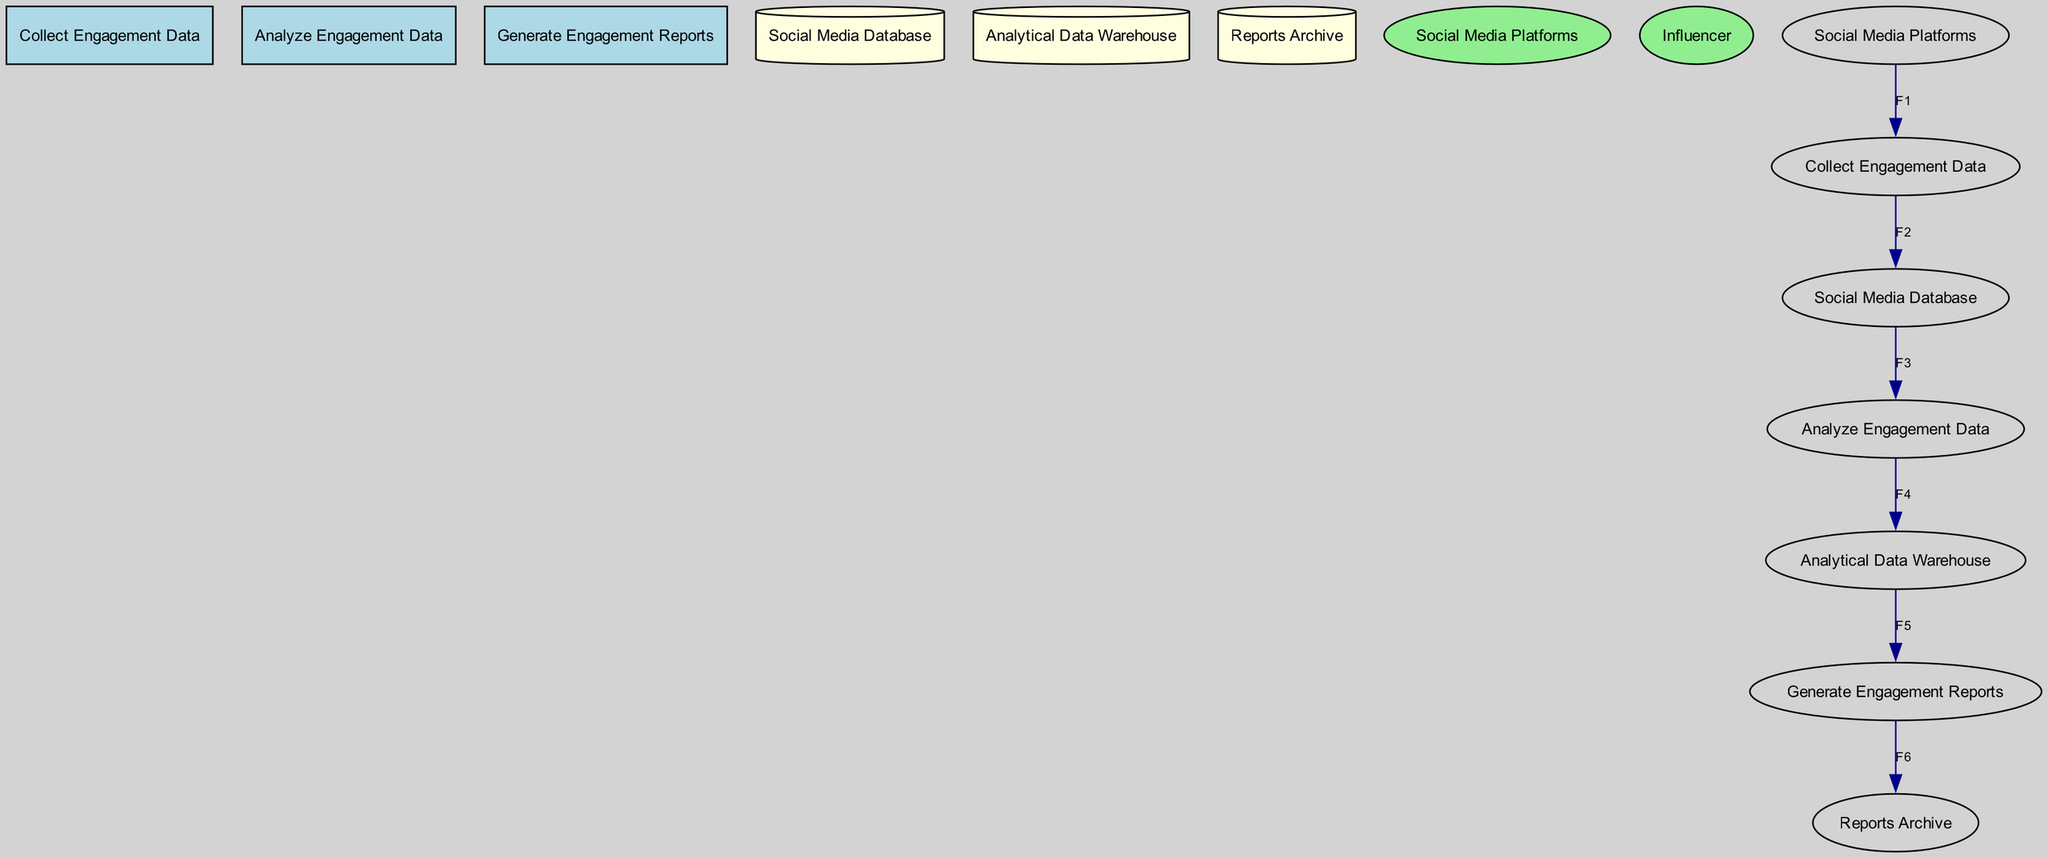What process collects engagement data? The diagram shows that the process responsible for collecting engagement data is labeled as "Collect Engagement Data."
Answer: Collect Engagement Data What is the destination of the data flow F3? According to the diagram, data flow F3 originates from the "Social Media Database" and flows to "Analyze Engagement Data."
Answer: Analyze Engagement Data How many data stores are depicted in the diagram? The diagram lists three data stores: "Social Media Database," "Analytical Data Warehouse," and "Reports Archive," totaling three.
Answer: 3 What type of entity is "Social Media Platforms"? The diagram classifies "Social Media Platforms" as an external entity, indicated by its ellipse shape.
Answer: External entity What is the final destination of the processed data? The diagram indicates that the processed data ends at the "Reports Archive," as it is where the generated reports are stored.
Answer: Reports Archive What flows from "Generate Engagement Reports" to "Reports Archive"? In the diagram, data flow F6, which represents generated reports, flows from "Generate Engagement Reports" to "Reports Archive."
Answer: F6 What data is analyzed in the "Analyze Engagement Data" process? The process "Analyze Engagement Data" receives raw data from the "Social Media Database," which contains raw user interaction data.
Answer: Raw user interaction data What is the relationship between "Analyze Engagement Data" and "Analytical Data Warehouse"? The relationship is indicated by data flow F4, where processed engagement data moves from "Analyze Engagement Data" to "Analytical Data Warehouse."
Answer: F4 Which process generates detailed engagement reports? The process labeled "Generate Engagement Reports" is specifically responsible for creating detailed engagement reports based on analyzed data.
Answer: Generate Engagement Reports 